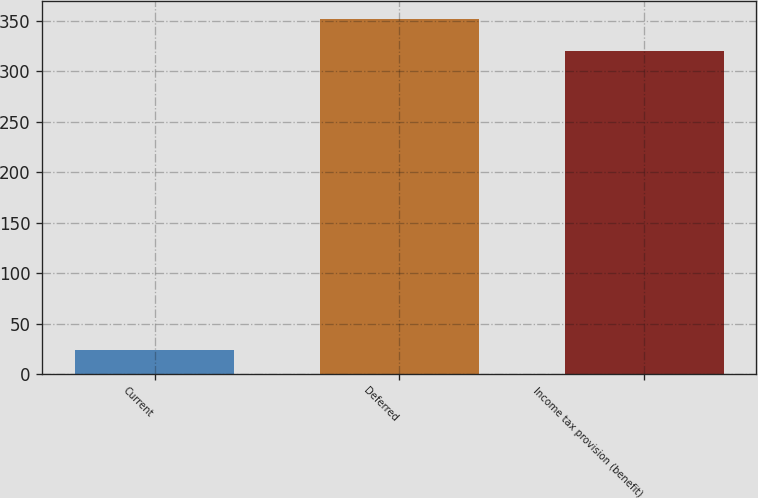Convert chart. <chart><loc_0><loc_0><loc_500><loc_500><bar_chart><fcel>Current<fcel>Deferred<fcel>Income tax provision (benefit)<nl><fcel>24<fcel>352<fcel>320<nl></chart> 